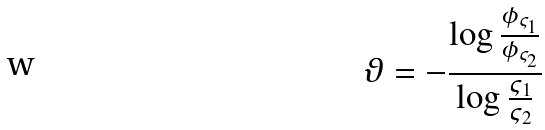<formula> <loc_0><loc_0><loc_500><loc_500>\vartheta = - \frac { \log \frac { \phi _ { \varsigma _ { 1 } } } { \phi _ { \varsigma _ { 2 } } } } { \log \frac { \varsigma _ { 1 } } { \varsigma _ { 2 } } }</formula> 